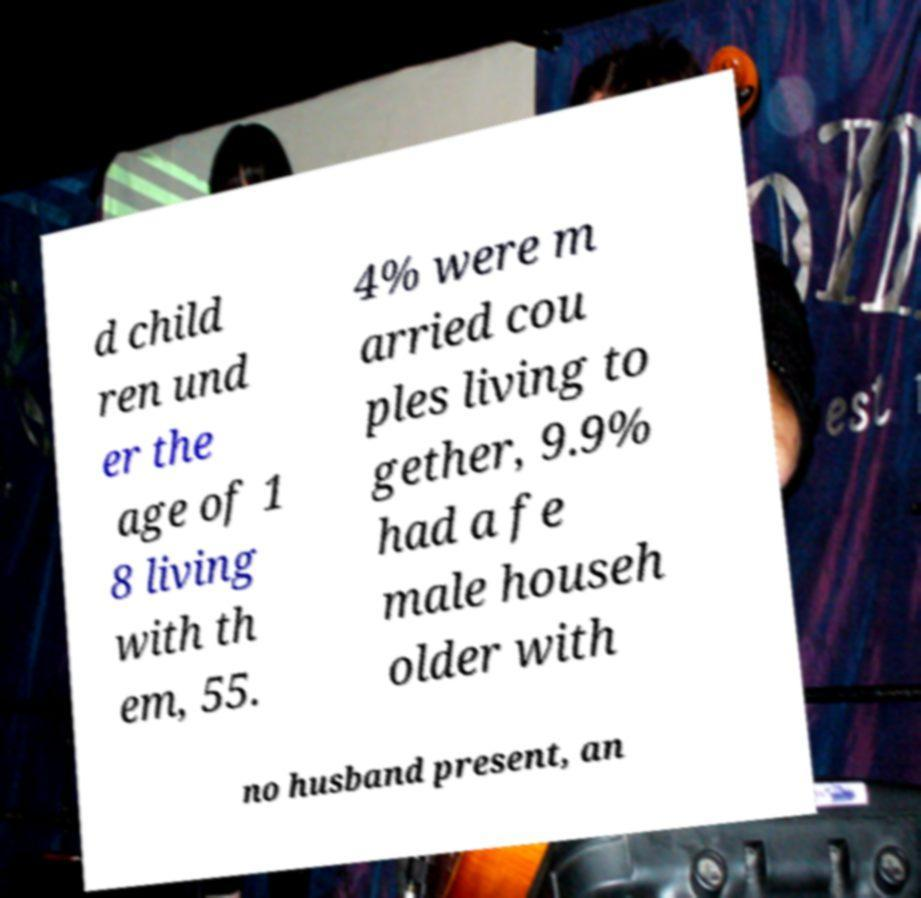Please read and relay the text visible in this image. What does it say? d child ren und er the age of 1 8 living with th em, 55. 4% were m arried cou ples living to gether, 9.9% had a fe male househ older with no husband present, an 